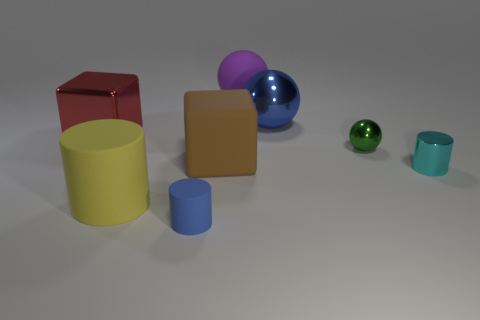Is there a sphere that has the same color as the tiny matte object? Yes, there is a sphere in the image that has a similar color to the tiny matte object. The sphere appears to be a shade of green that closely matches the smaller object's hue, although the materials' differing matte and shiny finishes might slightly affect the perception of color. 